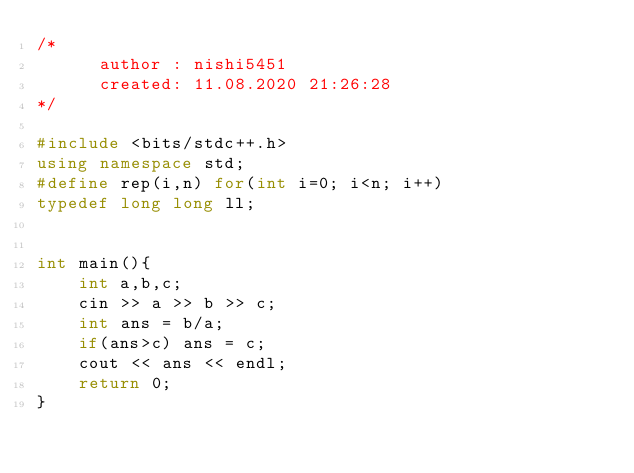Convert code to text. <code><loc_0><loc_0><loc_500><loc_500><_C++_>/*
      author : nishi5451
      created: 11.08.2020 21:26:28
*/

#include <bits/stdc++.h>
using namespace std;
#define rep(i,n) for(int i=0; i<n; i++)
typedef long long ll;


int main(){
    int a,b,c;
    cin >> a >> b >> c;
    int ans = b/a;
    if(ans>c) ans = c;
    cout << ans << endl;
    return 0;
}</code> 